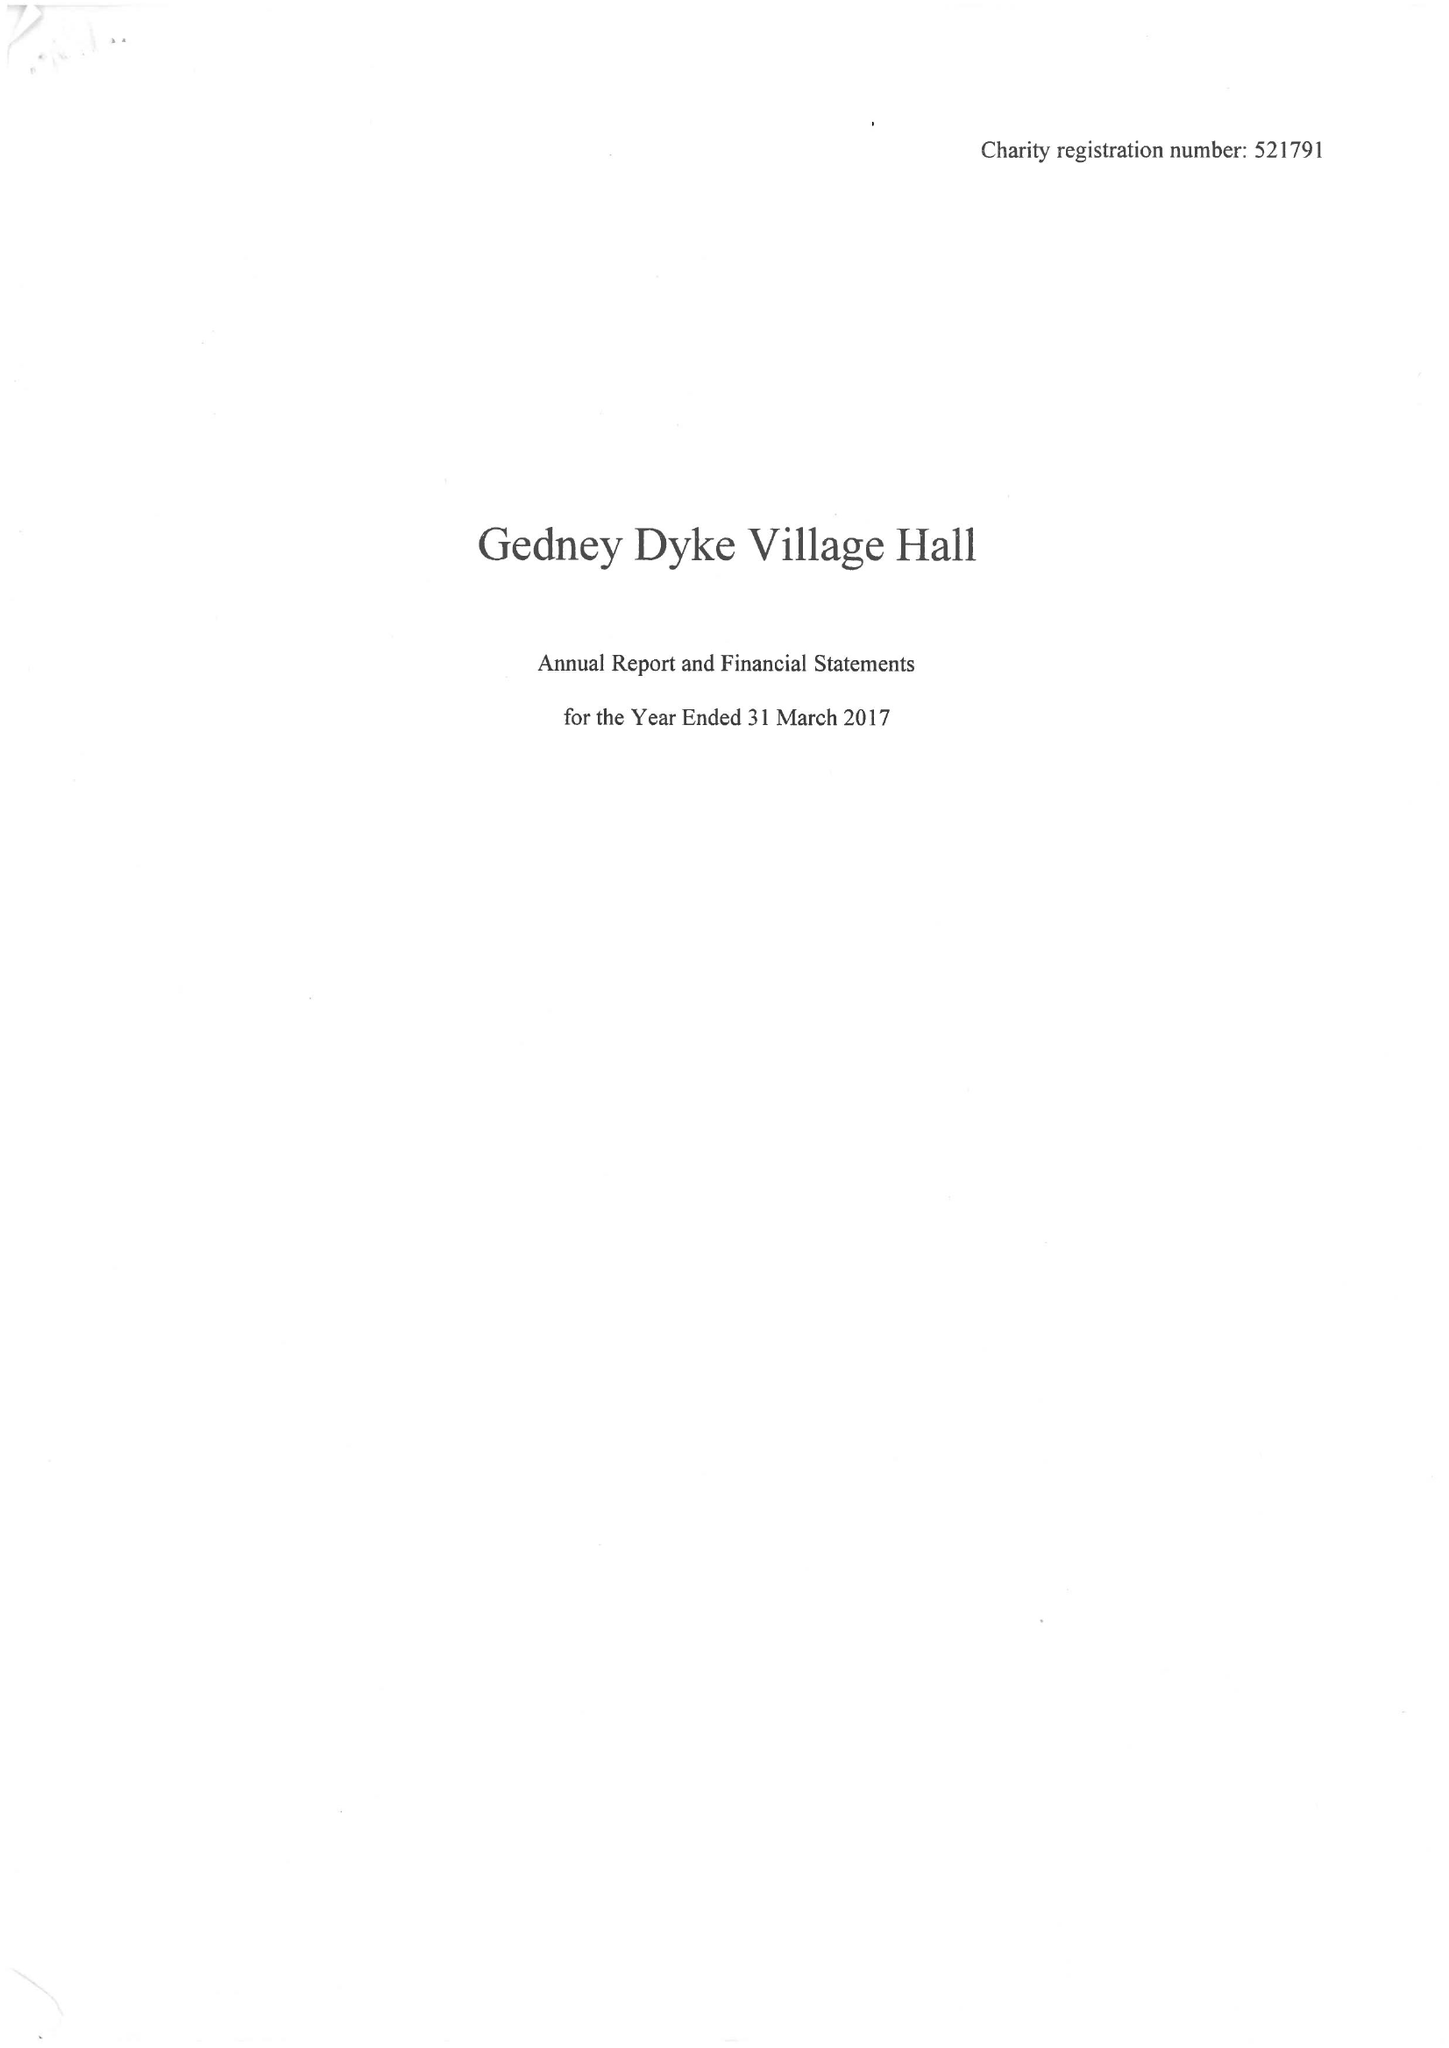What is the value for the charity_name?
Answer the question using a single word or phrase. Gedney Dyke Village Hall 